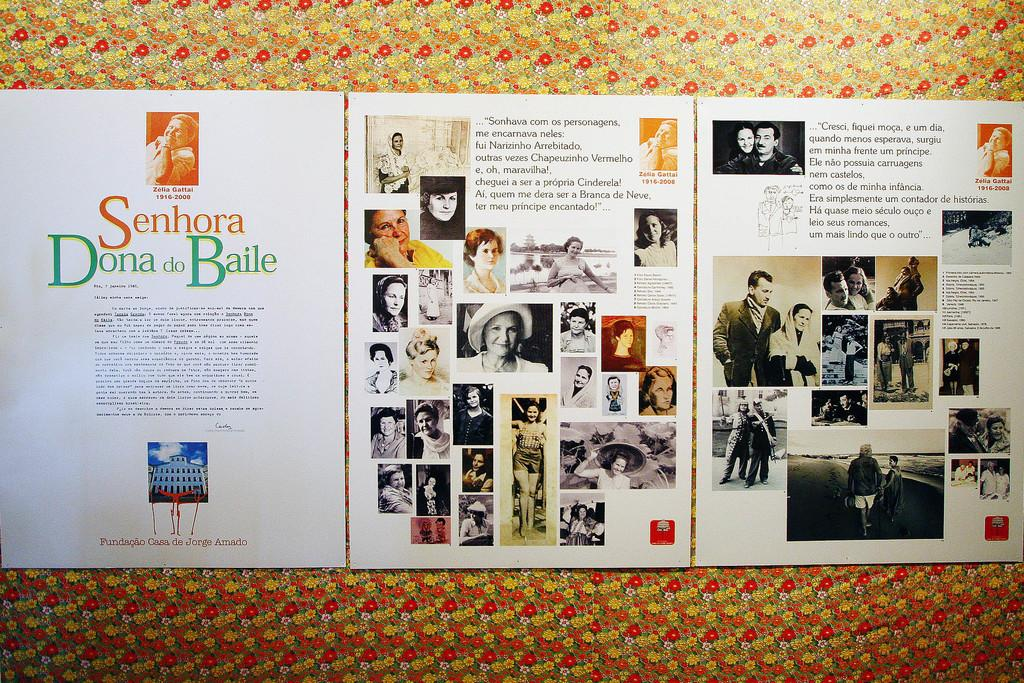<image>
Write a terse but informative summary of the picture. Senhora Dona do Baile with pictures included on the paper 